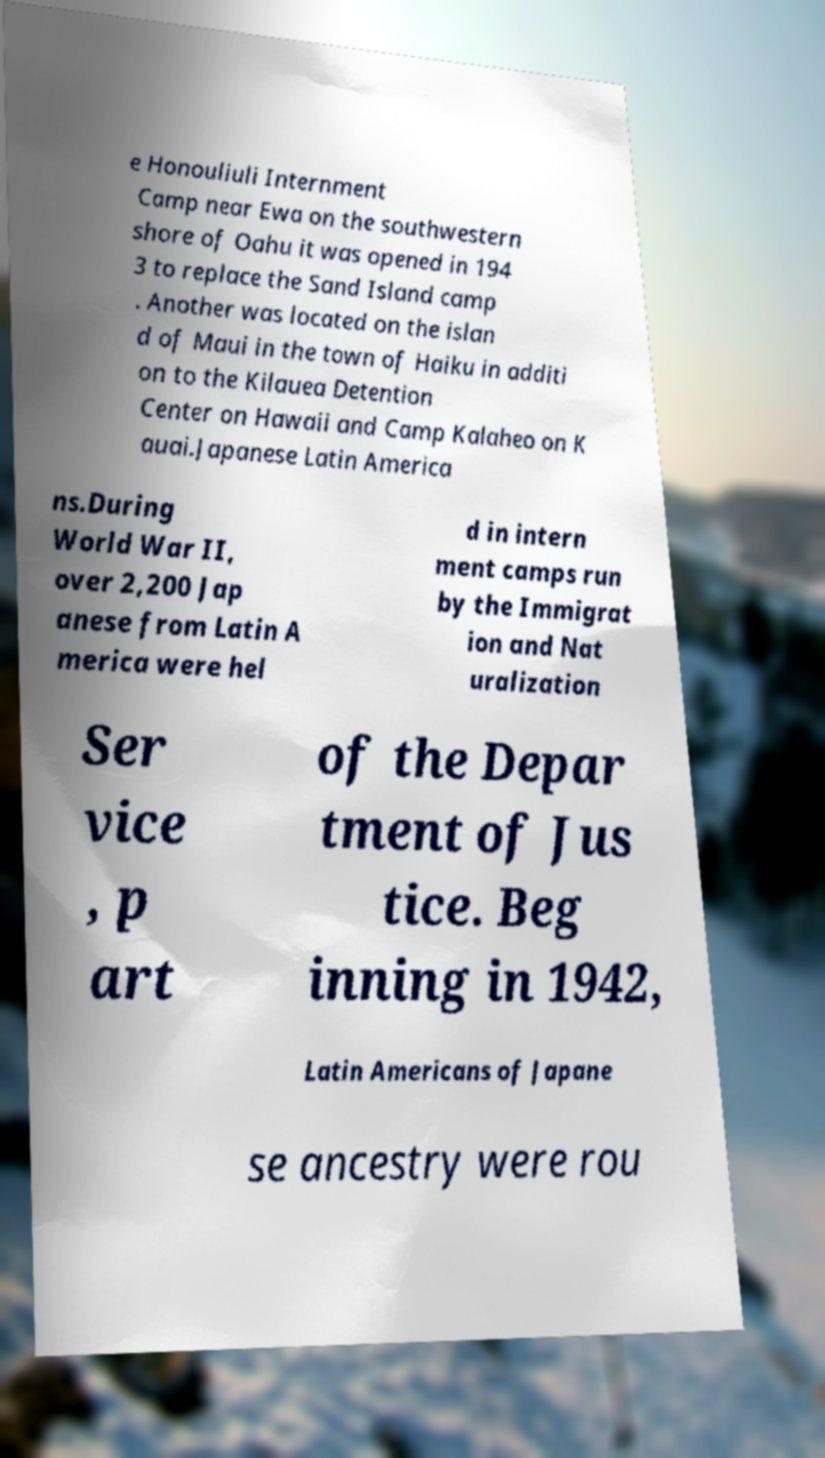Could you assist in decoding the text presented in this image and type it out clearly? e Honouliuli Internment Camp near Ewa on the southwestern shore of Oahu it was opened in 194 3 to replace the Sand Island camp . Another was located on the islan d of Maui in the town of Haiku in additi on to the Kilauea Detention Center on Hawaii and Camp Kalaheo on K auai.Japanese Latin America ns.During World War II, over 2,200 Jap anese from Latin A merica were hel d in intern ment camps run by the Immigrat ion and Nat uralization Ser vice , p art of the Depar tment of Jus tice. Beg inning in 1942, Latin Americans of Japane se ancestry were rou 